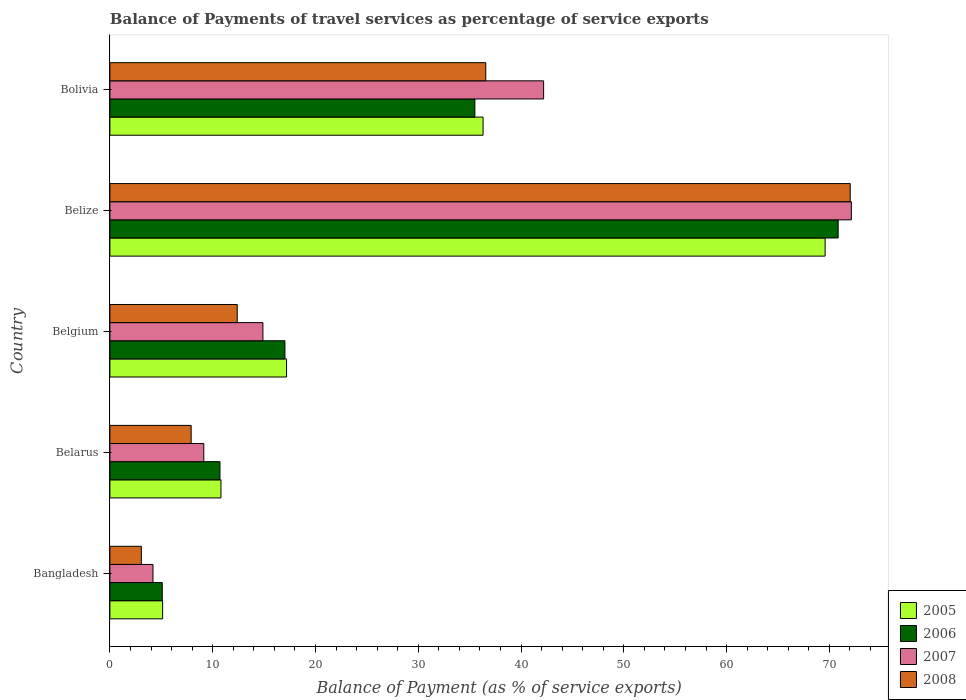How many groups of bars are there?
Provide a succinct answer. 5. How many bars are there on the 1st tick from the top?
Make the answer very short. 4. How many bars are there on the 2nd tick from the bottom?
Offer a very short reply. 4. What is the label of the 3rd group of bars from the top?
Your response must be concise. Belgium. What is the balance of payments of travel services in 2006 in Belgium?
Offer a terse response. 17.03. Across all countries, what is the maximum balance of payments of travel services in 2005?
Give a very brief answer. 69.59. Across all countries, what is the minimum balance of payments of travel services in 2008?
Keep it short and to the point. 3.06. In which country was the balance of payments of travel services in 2006 maximum?
Your answer should be very brief. Belize. In which country was the balance of payments of travel services in 2008 minimum?
Provide a short and direct response. Bangladesh. What is the total balance of payments of travel services in 2006 in the graph?
Your answer should be compact. 139.2. What is the difference between the balance of payments of travel services in 2006 in Belgium and that in Bolivia?
Give a very brief answer. -18.48. What is the difference between the balance of payments of travel services in 2006 in Belize and the balance of payments of travel services in 2005 in Belgium?
Your answer should be compact. 53.67. What is the average balance of payments of travel services in 2007 per country?
Offer a very short reply. 28.51. What is the difference between the balance of payments of travel services in 2006 and balance of payments of travel services in 2005 in Belgium?
Give a very brief answer. -0.16. What is the ratio of the balance of payments of travel services in 2005 in Belarus to that in Belize?
Your answer should be compact. 0.16. Is the difference between the balance of payments of travel services in 2006 in Belize and Bolivia greater than the difference between the balance of payments of travel services in 2005 in Belize and Bolivia?
Your answer should be compact. Yes. What is the difference between the highest and the second highest balance of payments of travel services in 2005?
Offer a very short reply. 33.28. What is the difference between the highest and the lowest balance of payments of travel services in 2008?
Offer a terse response. 68.97. In how many countries, is the balance of payments of travel services in 2007 greater than the average balance of payments of travel services in 2007 taken over all countries?
Provide a short and direct response. 2. Is the sum of the balance of payments of travel services in 2007 in Belgium and Belize greater than the maximum balance of payments of travel services in 2008 across all countries?
Provide a succinct answer. Yes. Is it the case that in every country, the sum of the balance of payments of travel services in 2008 and balance of payments of travel services in 2007 is greater than the sum of balance of payments of travel services in 2005 and balance of payments of travel services in 2006?
Provide a short and direct response. No. What does the 4th bar from the bottom in Belarus represents?
Make the answer very short. 2008. How many bars are there?
Offer a very short reply. 20. Are the values on the major ticks of X-axis written in scientific E-notation?
Ensure brevity in your answer.  No. Does the graph contain any zero values?
Make the answer very short. No. Does the graph contain grids?
Your answer should be very brief. No. Where does the legend appear in the graph?
Make the answer very short. Bottom right. How many legend labels are there?
Keep it short and to the point. 4. What is the title of the graph?
Give a very brief answer. Balance of Payments of travel services as percentage of service exports. Does "1981" appear as one of the legend labels in the graph?
Your answer should be compact. No. What is the label or title of the X-axis?
Your answer should be very brief. Balance of Payment (as % of service exports). What is the label or title of the Y-axis?
Provide a short and direct response. Country. What is the Balance of Payment (as % of service exports) of 2005 in Bangladesh?
Offer a terse response. 5.13. What is the Balance of Payment (as % of service exports) in 2006 in Bangladesh?
Keep it short and to the point. 5.1. What is the Balance of Payment (as % of service exports) of 2007 in Bangladesh?
Your answer should be very brief. 4.19. What is the Balance of Payment (as % of service exports) in 2008 in Bangladesh?
Offer a very short reply. 3.06. What is the Balance of Payment (as % of service exports) of 2005 in Belarus?
Your answer should be compact. 10.81. What is the Balance of Payment (as % of service exports) of 2006 in Belarus?
Provide a short and direct response. 10.71. What is the Balance of Payment (as % of service exports) of 2007 in Belarus?
Give a very brief answer. 9.14. What is the Balance of Payment (as % of service exports) in 2008 in Belarus?
Your response must be concise. 7.91. What is the Balance of Payment (as % of service exports) in 2005 in Belgium?
Provide a succinct answer. 17.19. What is the Balance of Payment (as % of service exports) in 2006 in Belgium?
Your response must be concise. 17.03. What is the Balance of Payment (as % of service exports) in 2007 in Belgium?
Give a very brief answer. 14.89. What is the Balance of Payment (as % of service exports) in 2008 in Belgium?
Ensure brevity in your answer.  12.39. What is the Balance of Payment (as % of service exports) of 2005 in Belize?
Your answer should be very brief. 69.59. What is the Balance of Payment (as % of service exports) in 2006 in Belize?
Give a very brief answer. 70.86. What is the Balance of Payment (as % of service exports) in 2007 in Belize?
Provide a short and direct response. 72.14. What is the Balance of Payment (as % of service exports) of 2008 in Belize?
Make the answer very short. 72.03. What is the Balance of Payment (as % of service exports) in 2005 in Bolivia?
Provide a short and direct response. 36.31. What is the Balance of Payment (as % of service exports) of 2006 in Bolivia?
Ensure brevity in your answer.  35.51. What is the Balance of Payment (as % of service exports) in 2007 in Bolivia?
Offer a very short reply. 42.2. What is the Balance of Payment (as % of service exports) in 2008 in Bolivia?
Provide a succinct answer. 36.57. Across all countries, what is the maximum Balance of Payment (as % of service exports) in 2005?
Your answer should be very brief. 69.59. Across all countries, what is the maximum Balance of Payment (as % of service exports) of 2006?
Provide a succinct answer. 70.86. Across all countries, what is the maximum Balance of Payment (as % of service exports) of 2007?
Your response must be concise. 72.14. Across all countries, what is the maximum Balance of Payment (as % of service exports) in 2008?
Provide a succinct answer. 72.03. Across all countries, what is the minimum Balance of Payment (as % of service exports) in 2005?
Offer a very short reply. 5.13. Across all countries, what is the minimum Balance of Payment (as % of service exports) in 2006?
Your answer should be compact. 5.1. Across all countries, what is the minimum Balance of Payment (as % of service exports) in 2007?
Offer a very short reply. 4.19. Across all countries, what is the minimum Balance of Payment (as % of service exports) of 2008?
Offer a terse response. 3.06. What is the total Balance of Payment (as % of service exports) of 2005 in the graph?
Offer a terse response. 139.03. What is the total Balance of Payment (as % of service exports) in 2006 in the graph?
Make the answer very short. 139.2. What is the total Balance of Payment (as % of service exports) in 2007 in the graph?
Your answer should be compact. 142.56. What is the total Balance of Payment (as % of service exports) in 2008 in the graph?
Provide a short and direct response. 131.96. What is the difference between the Balance of Payment (as % of service exports) of 2005 in Bangladesh and that in Belarus?
Offer a terse response. -5.67. What is the difference between the Balance of Payment (as % of service exports) in 2006 in Bangladesh and that in Belarus?
Offer a terse response. -5.61. What is the difference between the Balance of Payment (as % of service exports) in 2007 in Bangladesh and that in Belarus?
Offer a very short reply. -4.94. What is the difference between the Balance of Payment (as % of service exports) of 2008 in Bangladesh and that in Belarus?
Offer a very short reply. -4.85. What is the difference between the Balance of Payment (as % of service exports) in 2005 in Bangladesh and that in Belgium?
Give a very brief answer. -12.06. What is the difference between the Balance of Payment (as % of service exports) in 2006 in Bangladesh and that in Belgium?
Make the answer very short. -11.94. What is the difference between the Balance of Payment (as % of service exports) of 2007 in Bangladesh and that in Belgium?
Your response must be concise. -10.69. What is the difference between the Balance of Payment (as % of service exports) in 2008 in Bangladesh and that in Belgium?
Your answer should be compact. -9.33. What is the difference between the Balance of Payment (as % of service exports) of 2005 in Bangladesh and that in Belize?
Give a very brief answer. -64.46. What is the difference between the Balance of Payment (as % of service exports) in 2006 in Bangladesh and that in Belize?
Provide a succinct answer. -65.76. What is the difference between the Balance of Payment (as % of service exports) of 2007 in Bangladesh and that in Belize?
Make the answer very short. -67.95. What is the difference between the Balance of Payment (as % of service exports) of 2008 in Bangladesh and that in Belize?
Offer a very short reply. -68.97. What is the difference between the Balance of Payment (as % of service exports) in 2005 in Bangladesh and that in Bolivia?
Provide a short and direct response. -31.18. What is the difference between the Balance of Payment (as % of service exports) of 2006 in Bangladesh and that in Bolivia?
Provide a succinct answer. -30.41. What is the difference between the Balance of Payment (as % of service exports) of 2007 in Bangladesh and that in Bolivia?
Provide a succinct answer. -38.01. What is the difference between the Balance of Payment (as % of service exports) of 2008 in Bangladesh and that in Bolivia?
Give a very brief answer. -33.51. What is the difference between the Balance of Payment (as % of service exports) in 2005 in Belarus and that in Belgium?
Provide a succinct answer. -6.38. What is the difference between the Balance of Payment (as % of service exports) of 2006 in Belarus and that in Belgium?
Give a very brief answer. -6.32. What is the difference between the Balance of Payment (as % of service exports) in 2007 in Belarus and that in Belgium?
Provide a short and direct response. -5.75. What is the difference between the Balance of Payment (as % of service exports) of 2008 in Belarus and that in Belgium?
Provide a succinct answer. -4.48. What is the difference between the Balance of Payment (as % of service exports) in 2005 in Belarus and that in Belize?
Your answer should be very brief. -58.78. What is the difference between the Balance of Payment (as % of service exports) in 2006 in Belarus and that in Belize?
Offer a terse response. -60.15. What is the difference between the Balance of Payment (as % of service exports) of 2007 in Belarus and that in Belize?
Give a very brief answer. -63.01. What is the difference between the Balance of Payment (as % of service exports) in 2008 in Belarus and that in Belize?
Give a very brief answer. -64.13. What is the difference between the Balance of Payment (as % of service exports) of 2005 in Belarus and that in Bolivia?
Give a very brief answer. -25.5. What is the difference between the Balance of Payment (as % of service exports) of 2006 in Belarus and that in Bolivia?
Your answer should be compact. -24.8. What is the difference between the Balance of Payment (as % of service exports) in 2007 in Belarus and that in Bolivia?
Make the answer very short. -33.07. What is the difference between the Balance of Payment (as % of service exports) in 2008 in Belarus and that in Bolivia?
Ensure brevity in your answer.  -28.67. What is the difference between the Balance of Payment (as % of service exports) of 2005 in Belgium and that in Belize?
Give a very brief answer. -52.4. What is the difference between the Balance of Payment (as % of service exports) in 2006 in Belgium and that in Belize?
Your response must be concise. -53.83. What is the difference between the Balance of Payment (as % of service exports) of 2007 in Belgium and that in Belize?
Offer a terse response. -57.26. What is the difference between the Balance of Payment (as % of service exports) in 2008 in Belgium and that in Belize?
Make the answer very short. -59.65. What is the difference between the Balance of Payment (as % of service exports) of 2005 in Belgium and that in Bolivia?
Give a very brief answer. -19.12. What is the difference between the Balance of Payment (as % of service exports) of 2006 in Belgium and that in Bolivia?
Give a very brief answer. -18.48. What is the difference between the Balance of Payment (as % of service exports) in 2007 in Belgium and that in Bolivia?
Your response must be concise. -27.31. What is the difference between the Balance of Payment (as % of service exports) of 2008 in Belgium and that in Bolivia?
Keep it short and to the point. -24.18. What is the difference between the Balance of Payment (as % of service exports) of 2005 in Belize and that in Bolivia?
Keep it short and to the point. 33.28. What is the difference between the Balance of Payment (as % of service exports) in 2006 in Belize and that in Bolivia?
Your response must be concise. 35.35. What is the difference between the Balance of Payment (as % of service exports) of 2007 in Belize and that in Bolivia?
Your answer should be very brief. 29.94. What is the difference between the Balance of Payment (as % of service exports) of 2008 in Belize and that in Bolivia?
Offer a very short reply. 35.46. What is the difference between the Balance of Payment (as % of service exports) of 2005 in Bangladesh and the Balance of Payment (as % of service exports) of 2006 in Belarus?
Your response must be concise. -5.58. What is the difference between the Balance of Payment (as % of service exports) of 2005 in Bangladesh and the Balance of Payment (as % of service exports) of 2007 in Belarus?
Your response must be concise. -4.01. What is the difference between the Balance of Payment (as % of service exports) of 2005 in Bangladesh and the Balance of Payment (as % of service exports) of 2008 in Belarus?
Your response must be concise. -2.78. What is the difference between the Balance of Payment (as % of service exports) in 2006 in Bangladesh and the Balance of Payment (as % of service exports) in 2007 in Belarus?
Provide a succinct answer. -4.04. What is the difference between the Balance of Payment (as % of service exports) of 2006 in Bangladesh and the Balance of Payment (as % of service exports) of 2008 in Belarus?
Your response must be concise. -2.81. What is the difference between the Balance of Payment (as % of service exports) of 2007 in Bangladesh and the Balance of Payment (as % of service exports) of 2008 in Belarus?
Your answer should be very brief. -3.71. What is the difference between the Balance of Payment (as % of service exports) of 2005 in Bangladesh and the Balance of Payment (as % of service exports) of 2006 in Belgium?
Provide a short and direct response. -11.9. What is the difference between the Balance of Payment (as % of service exports) of 2005 in Bangladesh and the Balance of Payment (as % of service exports) of 2007 in Belgium?
Offer a terse response. -9.76. What is the difference between the Balance of Payment (as % of service exports) of 2005 in Bangladesh and the Balance of Payment (as % of service exports) of 2008 in Belgium?
Your answer should be compact. -7.26. What is the difference between the Balance of Payment (as % of service exports) of 2006 in Bangladesh and the Balance of Payment (as % of service exports) of 2007 in Belgium?
Give a very brief answer. -9.79. What is the difference between the Balance of Payment (as % of service exports) of 2006 in Bangladesh and the Balance of Payment (as % of service exports) of 2008 in Belgium?
Your response must be concise. -7.29. What is the difference between the Balance of Payment (as % of service exports) in 2007 in Bangladesh and the Balance of Payment (as % of service exports) in 2008 in Belgium?
Your answer should be very brief. -8.2. What is the difference between the Balance of Payment (as % of service exports) of 2005 in Bangladesh and the Balance of Payment (as % of service exports) of 2006 in Belize?
Offer a very short reply. -65.73. What is the difference between the Balance of Payment (as % of service exports) of 2005 in Bangladesh and the Balance of Payment (as % of service exports) of 2007 in Belize?
Your response must be concise. -67.01. What is the difference between the Balance of Payment (as % of service exports) of 2005 in Bangladesh and the Balance of Payment (as % of service exports) of 2008 in Belize?
Offer a terse response. -66.9. What is the difference between the Balance of Payment (as % of service exports) in 2006 in Bangladesh and the Balance of Payment (as % of service exports) in 2007 in Belize?
Your response must be concise. -67.05. What is the difference between the Balance of Payment (as % of service exports) in 2006 in Bangladesh and the Balance of Payment (as % of service exports) in 2008 in Belize?
Offer a terse response. -66.94. What is the difference between the Balance of Payment (as % of service exports) of 2007 in Bangladesh and the Balance of Payment (as % of service exports) of 2008 in Belize?
Keep it short and to the point. -67.84. What is the difference between the Balance of Payment (as % of service exports) in 2005 in Bangladesh and the Balance of Payment (as % of service exports) in 2006 in Bolivia?
Provide a succinct answer. -30.38. What is the difference between the Balance of Payment (as % of service exports) in 2005 in Bangladesh and the Balance of Payment (as % of service exports) in 2007 in Bolivia?
Provide a succinct answer. -37.07. What is the difference between the Balance of Payment (as % of service exports) of 2005 in Bangladesh and the Balance of Payment (as % of service exports) of 2008 in Bolivia?
Your answer should be compact. -31.44. What is the difference between the Balance of Payment (as % of service exports) of 2006 in Bangladesh and the Balance of Payment (as % of service exports) of 2007 in Bolivia?
Offer a very short reply. -37.11. What is the difference between the Balance of Payment (as % of service exports) in 2006 in Bangladesh and the Balance of Payment (as % of service exports) in 2008 in Bolivia?
Give a very brief answer. -31.48. What is the difference between the Balance of Payment (as % of service exports) of 2007 in Bangladesh and the Balance of Payment (as % of service exports) of 2008 in Bolivia?
Ensure brevity in your answer.  -32.38. What is the difference between the Balance of Payment (as % of service exports) in 2005 in Belarus and the Balance of Payment (as % of service exports) in 2006 in Belgium?
Your answer should be very brief. -6.23. What is the difference between the Balance of Payment (as % of service exports) in 2005 in Belarus and the Balance of Payment (as % of service exports) in 2007 in Belgium?
Provide a succinct answer. -4.08. What is the difference between the Balance of Payment (as % of service exports) in 2005 in Belarus and the Balance of Payment (as % of service exports) in 2008 in Belgium?
Make the answer very short. -1.58. What is the difference between the Balance of Payment (as % of service exports) of 2006 in Belarus and the Balance of Payment (as % of service exports) of 2007 in Belgium?
Your response must be concise. -4.18. What is the difference between the Balance of Payment (as % of service exports) of 2006 in Belarus and the Balance of Payment (as % of service exports) of 2008 in Belgium?
Offer a terse response. -1.68. What is the difference between the Balance of Payment (as % of service exports) of 2007 in Belarus and the Balance of Payment (as % of service exports) of 2008 in Belgium?
Keep it short and to the point. -3.25. What is the difference between the Balance of Payment (as % of service exports) of 2005 in Belarus and the Balance of Payment (as % of service exports) of 2006 in Belize?
Offer a terse response. -60.05. What is the difference between the Balance of Payment (as % of service exports) of 2005 in Belarus and the Balance of Payment (as % of service exports) of 2007 in Belize?
Your answer should be very brief. -61.34. What is the difference between the Balance of Payment (as % of service exports) in 2005 in Belarus and the Balance of Payment (as % of service exports) in 2008 in Belize?
Offer a very short reply. -61.23. What is the difference between the Balance of Payment (as % of service exports) of 2006 in Belarus and the Balance of Payment (as % of service exports) of 2007 in Belize?
Ensure brevity in your answer.  -61.43. What is the difference between the Balance of Payment (as % of service exports) of 2006 in Belarus and the Balance of Payment (as % of service exports) of 2008 in Belize?
Make the answer very short. -61.33. What is the difference between the Balance of Payment (as % of service exports) in 2007 in Belarus and the Balance of Payment (as % of service exports) in 2008 in Belize?
Your answer should be very brief. -62.9. What is the difference between the Balance of Payment (as % of service exports) in 2005 in Belarus and the Balance of Payment (as % of service exports) in 2006 in Bolivia?
Give a very brief answer. -24.7. What is the difference between the Balance of Payment (as % of service exports) in 2005 in Belarus and the Balance of Payment (as % of service exports) in 2007 in Bolivia?
Make the answer very short. -31.4. What is the difference between the Balance of Payment (as % of service exports) in 2005 in Belarus and the Balance of Payment (as % of service exports) in 2008 in Bolivia?
Offer a very short reply. -25.77. What is the difference between the Balance of Payment (as % of service exports) in 2006 in Belarus and the Balance of Payment (as % of service exports) in 2007 in Bolivia?
Give a very brief answer. -31.49. What is the difference between the Balance of Payment (as % of service exports) in 2006 in Belarus and the Balance of Payment (as % of service exports) in 2008 in Bolivia?
Offer a terse response. -25.86. What is the difference between the Balance of Payment (as % of service exports) of 2007 in Belarus and the Balance of Payment (as % of service exports) of 2008 in Bolivia?
Offer a terse response. -27.44. What is the difference between the Balance of Payment (as % of service exports) in 2005 in Belgium and the Balance of Payment (as % of service exports) in 2006 in Belize?
Give a very brief answer. -53.67. What is the difference between the Balance of Payment (as % of service exports) of 2005 in Belgium and the Balance of Payment (as % of service exports) of 2007 in Belize?
Ensure brevity in your answer.  -54.95. What is the difference between the Balance of Payment (as % of service exports) in 2005 in Belgium and the Balance of Payment (as % of service exports) in 2008 in Belize?
Ensure brevity in your answer.  -54.85. What is the difference between the Balance of Payment (as % of service exports) of 2006 in Belgium and the Balance of Payment (as % of service exports) of 2007 in Belize?
Provide a succinct answer. -55.11. What is the difference between the Balance of Payment (as % of service exports) of 2006 in Belgium and the Balance of Payment (as % of service exports) of 2008 in Belize?
Offer a very short reply. -55. What is the difference between the Balance of Payment (as % of service exports) of 2007 in Belgium and the Balance of Payment (as % of service exports) of 2008 in Belize?
Your answer should be compact. -57.15. What is the difference between the Balance of Payment (as % of service exports) in 2005 in Belgium and the Balance of Payment (as % of service exports) in 2006 in Bolivia?
Offer a terse response. -18.32. What is the difference between the Balance of Payment (as % of service exports) of 2005 in Belgium and the Balance of Payment (as % of service exports) of 2007 in Bolivia?
Ensure brevity in your answer.  -25.01. What is the difference between the Balance of Payment (as % of service exports) in 2005 in Belgium and the Balance of Payment (as % of service exports) in 2008 in Bolivia?
Give a very brief answer. -19.38. What is the difference between the Balance of Payment (as % of service exports) of 2006 in Belgium and the Balance of Payment (as % of service exports) of 2007 in Bolivia?
Provide a short and direct response. -25.17. What is the difference between the Balance of Payment (as % of service exports) of 2006 in Belgium and the Balance of Payment (as % of service exports) of 2008 in Bolivia?
Provide a short and direct response. -19.54. What is the difference between the Balance of Payment (as % of service exports) in 2007 in Belgium and the Balance of Payment (as % of service exports) in 2008 in Bolivia?
Your answer should be compact. -21.68. What is the difference between the Balance of Payment (as % of service exports) of 2005 in Belize and the Balance of Payment (as % of service exports) of 2006 in Bolivia?
Make the answer very short. 34.08. What is the difference between the Balance of Payment (as % of service exports) in 2005 in Belize and the Balance of Payment (as % of service exports) in 2007 in Bolivia?
Your response must be concise. 27.39. What is the difference between the Balance of Payment (as % of service exports) of 2005 in Belize and the Balance of Payment (as % of service exports) of 2008 in Bolivia?
Offer a terse response. 33.02. What is the difference between the Balance of Payment (as % of service exports) of 2006 in Belize and the Balance of Payment (as % of service exports) of 2007 in Bolivia?
Your response must be concise. 28.66. What is the difference between the Balance of Payment (as % of service exports) in 2006 in Belize and the Balance of Payment (as % of service exports) in 2008 in Bolivia?
Offer a terse response. 34.29. What is the difference between the Balance of Payment (as % of service exports) of 2007 in Belize and the Balance of Payment (as % of service exports) of 2008 in Bolivia?
Give a very brief answer. 35.57. What is the average Balance of Payment (as % of service exports) in 2005 per country?
Provide a short and direct response. 27.81. What is the average Balance of Payment (as % of service exports) of 2006 per country?
Your response must be concise. 27.84. What is the average Balance of Payment (as % of service exports) in 2007 per country?
Your answer should be very brief. 28.51. What is the average Balance of Payment (as % of service exports) in 2008 per country?
Give a very brief answer. 26.39. What is the difference between the Balance of Payment (as % of service exports) of 2005 and Balance of Payment (as % of service exports) of 2006 in Bangladesh?
Your answer should be very brief. 0.04. What is the difference between the Balance of Payment (as % of service exports) in 2005 and Balance of Payment (as % of service exports) in 2007 in Bangladesh?
Provide a succinct answer. 0.94. What is the difference between the Balance of Payment (as % of service exports) of 2005 and Balance of Payment (as % of service exports) of 2008 in Bangladesh?
Your answer should be very brief. 2.07. What is the difference between the Balance of Payment (as % of service exports) of 2006 and Balance of Payment (as % of service exports) of 2007 in Bangladesh?
Your answer should be very brief. 0.9. What is the difference between the Balance of Payment (as % of service exports) of 2006 and Balance of Payment (as % of service exports) of 2008 in Bangladesh?
Your answer should be compact. 2.04. What is the difference between the Balance of Payment (as % of service exports) in 2007 and Balance of Payment (as % of service exports) in 2008 in Bangladesh?
Offer a very short reply. 1.13. What is the difference between the Balance of Payment (as % of service exports) of 2005 and Balance of Payment (as % of service exports) of 2006 in Belarus?
Make the answer very short. 0.1. What is the difference between the Balance of Payment (as % of service exports) in 2005 and Balance of Payment (as % of service exports) in 2007 in Belarus?
Make the answer very short. 1.67. What is the difference between the Balance of Payment (as % of service exports) of 2005 and Balance of Payment (as % of service exports) of 2008 in Belarus?
Offer a very short reply. 2.9. What is the difference between the Balance of Payment (as % of service exports) of 2006 and Balance of Payment (as % of service exports) of 2007 in Belarus?
Your response must be concise. 1.57. What is the difference between the Balance of Payment (as % of service exports) in 2006 and Balance of Payment (as % of service exports) in 2008 in Belarus?
Keep it short and to the point. 2.8. What is the difference between the Balance of Payment (as % of service exports) of 2007 and Balance of Payment (as % of service exports) of 2008 in Belarus?
Make the answer very short. 1.23. What is the difference between the Balance of Payment (as % of service exports) in 2005 and Balance of Payment (as % of service exports) in 2006 in Belgium?
Your answer should be compact. 0.16. What is the difference between the Balance of Payment (as % of service exports) of 2005 and Balance of Payment (as % of service exports) of 2007 in Belgium?
Keep it short and to the point. 2.3. What is the difference between the Balance of Payment (as % of service exports) in 2005 and Balance of Payment (as % of service exports) in 2008 in Belgium?
Provide a succinct answer. 4.8. What is the difference between the Balance of Payment (as % of service exports) in 2006 and Balance of Payment (as % of service exports) in 2007 in Belgium?
Keep it short and to the point. 2.14. What is the difference between the Balance of Payment (as % of service exports) of 2006 and Balance of Payment (as % of service exports) of 2008 in Belgium?
Your response must be concise. 4.64. What is the difference between the Balance of Payment (as % of service exports) in 2007 and Balance of Payment (as % of service exports) in 2008 in Belgium?
Make the answer very short. 2.5. What is the difference between the Balance of Payment (as % of service exports) in 2005 and Balance of Payment (as % of service exports) in 2006 in Belize?
Keep it short and to the point. -1.27. What is the difference between the Balance of Payment (as % of service exports) of 2005 and Balance of Payment (as % of service exports) of 2007 in Belize?
Give a very brief answer. -2.55. What is the difference between the Balance of Payment (as % of service exports) of 2005 and Balance of Payment (as % of service exports) of 2008 in Belize?
Give a very brief answer. -2.44. What is the difference between the Balance of Payment (as % of service exports) in 2006 and Balance of Payment (as % of service exports) in 2007 in Belize?
Give a very brief answer. -1.28. What is the difference between the Balance of Payment (as % of service exports) of 2006 and Balance of Payment (as % of service exports) of 2008 in Belize?
Your answer should be very brief. -1.18. What is the difference between the Balance of Payment (as % of service exports) of 2007 and Balance of Payment (as % of service exports) of 2008 in Belize?
Offer a very short reply. 0.11. What is the difference between the Balance of Payment (as % of service exports) of 2005 and Balance of Payment (as % of service exports) of 2006 in Bolivia?
Offer a very short reply. 0.8. What is the difference between the Balance of Payment (as % of service exports) in 2005 and Balance of Payment (as % of service exports) in 2007 in Bolivia?
Your answer should be very brief. -5.89. What is the difference between the Balance of Payment (as % of service exports) in 2005 and Balance of Payment (as % of service exports) in 2008 in Bolivia?
Provide a short and direct response. -0.26. What is the difference between the Balance of Payment (as % of service exports) of 2006 and Balance of Payment (as % of service exports) of 2007 in Bolivia?
Keep it short and to the point. -6.69. What is the difference between the Balance of Payment (as % of service exports) of 2006 and Balance of Payment (as % of service exports) of 2008 in Bolivia?
Keep it short and to the point. -1.06. What is the difference between the Balance of Payment (as % of service exports) in 2007 and Balance of Payment (as % of service exports) in 2008 in Bolivia?
Keep it short and to the point. 5.63. What is the ratio of the Balance of Payment (as % of service exports) in 2005 in Bangladesh to that in Belarus?
Give a very brief answer. 0.47. What is the ratio of the Balance of Payment (as % of service exports) of 2006 in Bangladesh to that in Belarus?
Keep it short and to the point. 0.48. What is the ratio of the Balance of Payment (as % of service exports) of 2007 in Bangladesh to that in Belarus?
Your answer should be very brief. 0.46. What is the ratio of the Balance of Payment (as % of service exports) in 2008 in Bangladesh to that in Belarus?
Keep it short and to the point. 0.39. What is the ratio of the Balance of Payment (as % of service exports) in 2005 in Bangladesh to that in Belgium?
Keep it short and to the point. 0.3. What is the ratio of the Balance of Payment (as % of service exports) of 2006 in Bangladesh to that in Belgium?
Offer a terse response. 0.3. What is the ratio of the Balance of Payment (as % of service exports) in 2007 in Bangladesh to that in Belgium?
Provide a short and direct response. 0.28. What is the ratio of the Balance of Payment (as % of service exports) in 2008 in Bangladesh to that in Belgium?
Ensure brevity in your answer.  0.25. What is the ratio of the Balance of Payment (as % of service exports) of 2005 in Bangladesh to that in Belize?
Provide a succinct answer. 0.07. What is the ratio of the Balance of Payment (as % of service exports) of 2006 in Bangladesh to that in Belize?
Ensure brevity in your answer.  0.07. What is the ratio of the Balance of Payment (as % of service exports) in 2007 in Bangladesh to that in Belize?
Keep it short and to the point. 0.06. What is the ratio of the Balance of Payment (as % of service exports) of 2008 in Bangladesh to that in Belize?
Provide a succinct answer. 0.04. What is the ratio of the Balance of Payment (as % of service exports) in 2005 in Bangladesh to that in Bolivia?
Offer a very short reply. 0.14. What is the ratio of the Balance of Payment (as % of service exports) of 2006 in Bangladesh to that in Bolivia?
Offer a terse response. 0.14. What is the ratio of the Balance of Payment (as % of service exports) in 2007 in Bangladesh to that in Bolivia?
Keep it short and to the point. 0.1. What is the ratio of the Balance of Payment (as % of service exports) in 2008 in Bangladesh to that in Bolivia?
Your response must be concise. 0.08. What is the ratio of the Balance of Payment (as % of service exports) of 2005 in Belarus to that in Belgium?
Make the answer very short. 0.63. What is the ratio of the Balance of Payment (as % of service exports) in 2006 in Belarus to that in Belgium?
Your answer should be very brief. 0.63. What is the ratio of the Balance of Payment (as % of service exports) in 2007 in Belarus to that in Belgium?
Your answer should be very brief. 0.61. What is the ratio of the Balance of Payment (as % of service exports) of 2008 in Belarus to that in Belgium?
Ensure brevity in your answer.  0.64. What is the ratio of the Balance of Payment (as % of service exports) of 2005 in Belarus to that in Belize?
Offer a very short reply. 0.16. What is the ratio of the Balance of Payment (as % of service exports) in 2006 in Belarus to that in Belize?
Give a very brief answer. 0.15. What is the ratio of the Balance of Payment (as % of service exports) in 2007 in Belarus to that in Belize?
Your answer should be compact. 0.13. What is the ratio of the Balance of Payment (as % of service exports) in 2008 in Belarus to that in Belize?
Make the answer very short. 0.11. What is the ratio of the Balance of Payment (as % of service exports) of 2005 in Belarus to that in Bolivia?
Provide a short and direct response. 0.3. What is the ratio of the Balance of Payment (as % of service exports) in 2006 in Belarus to that in Bolivia?
Your answer should be very brief. 0.3. What is the ratio of the Balance of Payment (as % of service exports) in 2007 in Belarus to that in Bolivia?
Give a very brief answer. 0.22. What is the ratio of the Balance of Payment (as % of service exports) in 2008 in Belarus to that in Bolivia?
Give a very brief answer. 0.22. What is the ratio of the Balance of Payment (as % of service exports) of 2005 in Belgium to that in Belize?
Provide a succinct answer. 0.25. What is the ratio of the Balance of Payment (as % of service exports) in 2006 in Belgium to that in Belize?
Offer a very short reply. 0.24. What is the ratio of the Balance of Payment (as % of service exports) of 2007 in Belgium to that in Belize?
Give a very brief answer. 0.21. What is the ratio of the Balance of Payment (as % of service exports) of 2008 in Belgium to that in Belize?
Give a very brief answer. 0.17. What is the ratio of the Balance of Payment (as % of service exports) in 2005 in Belgium to that in Bolivia?
Keep it short and to the point. 0.47. What is the ratio of the Balance of Payment (as % of service exports) in 2006 in Belgium to that in Bolivia?
Your answer should be very brief. 0.48. What is the ratio of the Balance of Payment (as % of service exports) of 2007 in Belgium to that in Bolivia?
Your answer should be very brief. 0.35. What is the ratio of the Balance of Payment (as % of service exports) of 2008 in Belgium to that in Bolivia?
Offer a very short reply. 0.34. What is the ratio of the Balance of Payment (as % of service exports) of 2005 in Belize to that in Bolivia?
Your answer should be compact. 1.92. What is the ratio of the Balance of Payment (as % of service exports) of 2006 in Belize to that in Bolivia?
Keep it short and to the point. 2. What is the ratio of the Balance of Payment (as % of service exports) of 2007 in Belize to that in Bolivia?
Provide a short and direct response. 1.71. What is the ratio of the Balance of Payment (as % of service exports) of 2008 in Belize to that in Bolivia?
Your response must be concise. 1.97. What is the difference between the highest and the second highest Balance of Payment (as % of service exports) in 2005?
Provide a short and direct response. 33.28. What is the difference between the highest and the second highest Balance of Payment (as % of service exports) of 2006?
Your answer should be compact. 35.35. What is the difference between the highest and the second highest Balance of Payment (as % of service exports) in 2007?
Provide a short and direct response. 29.94. What is the difference between the highest and the second highest Balance of Payment (as % of service exports) in 2008?
Ensure brevity in your answer.  35.46. What is the difference between the highest and the lowest Balance of Payment (as % of service exports) of 2005?
Give a very brief answer. 64.46. What is the difference between the highest and the lowest Balance of Payment (as % of service exports) of 2006?
Provide a succinct answer. 65.76. What is the difference between the highest and the lowest Balance of Payment (as % of service exports) of 2007?
Give a very brief answer. 67.95. What is the difference between the highest and the lowest Balance of Payment (as % of service exports) in 2008?
Offer a very short reply. 68.97. 